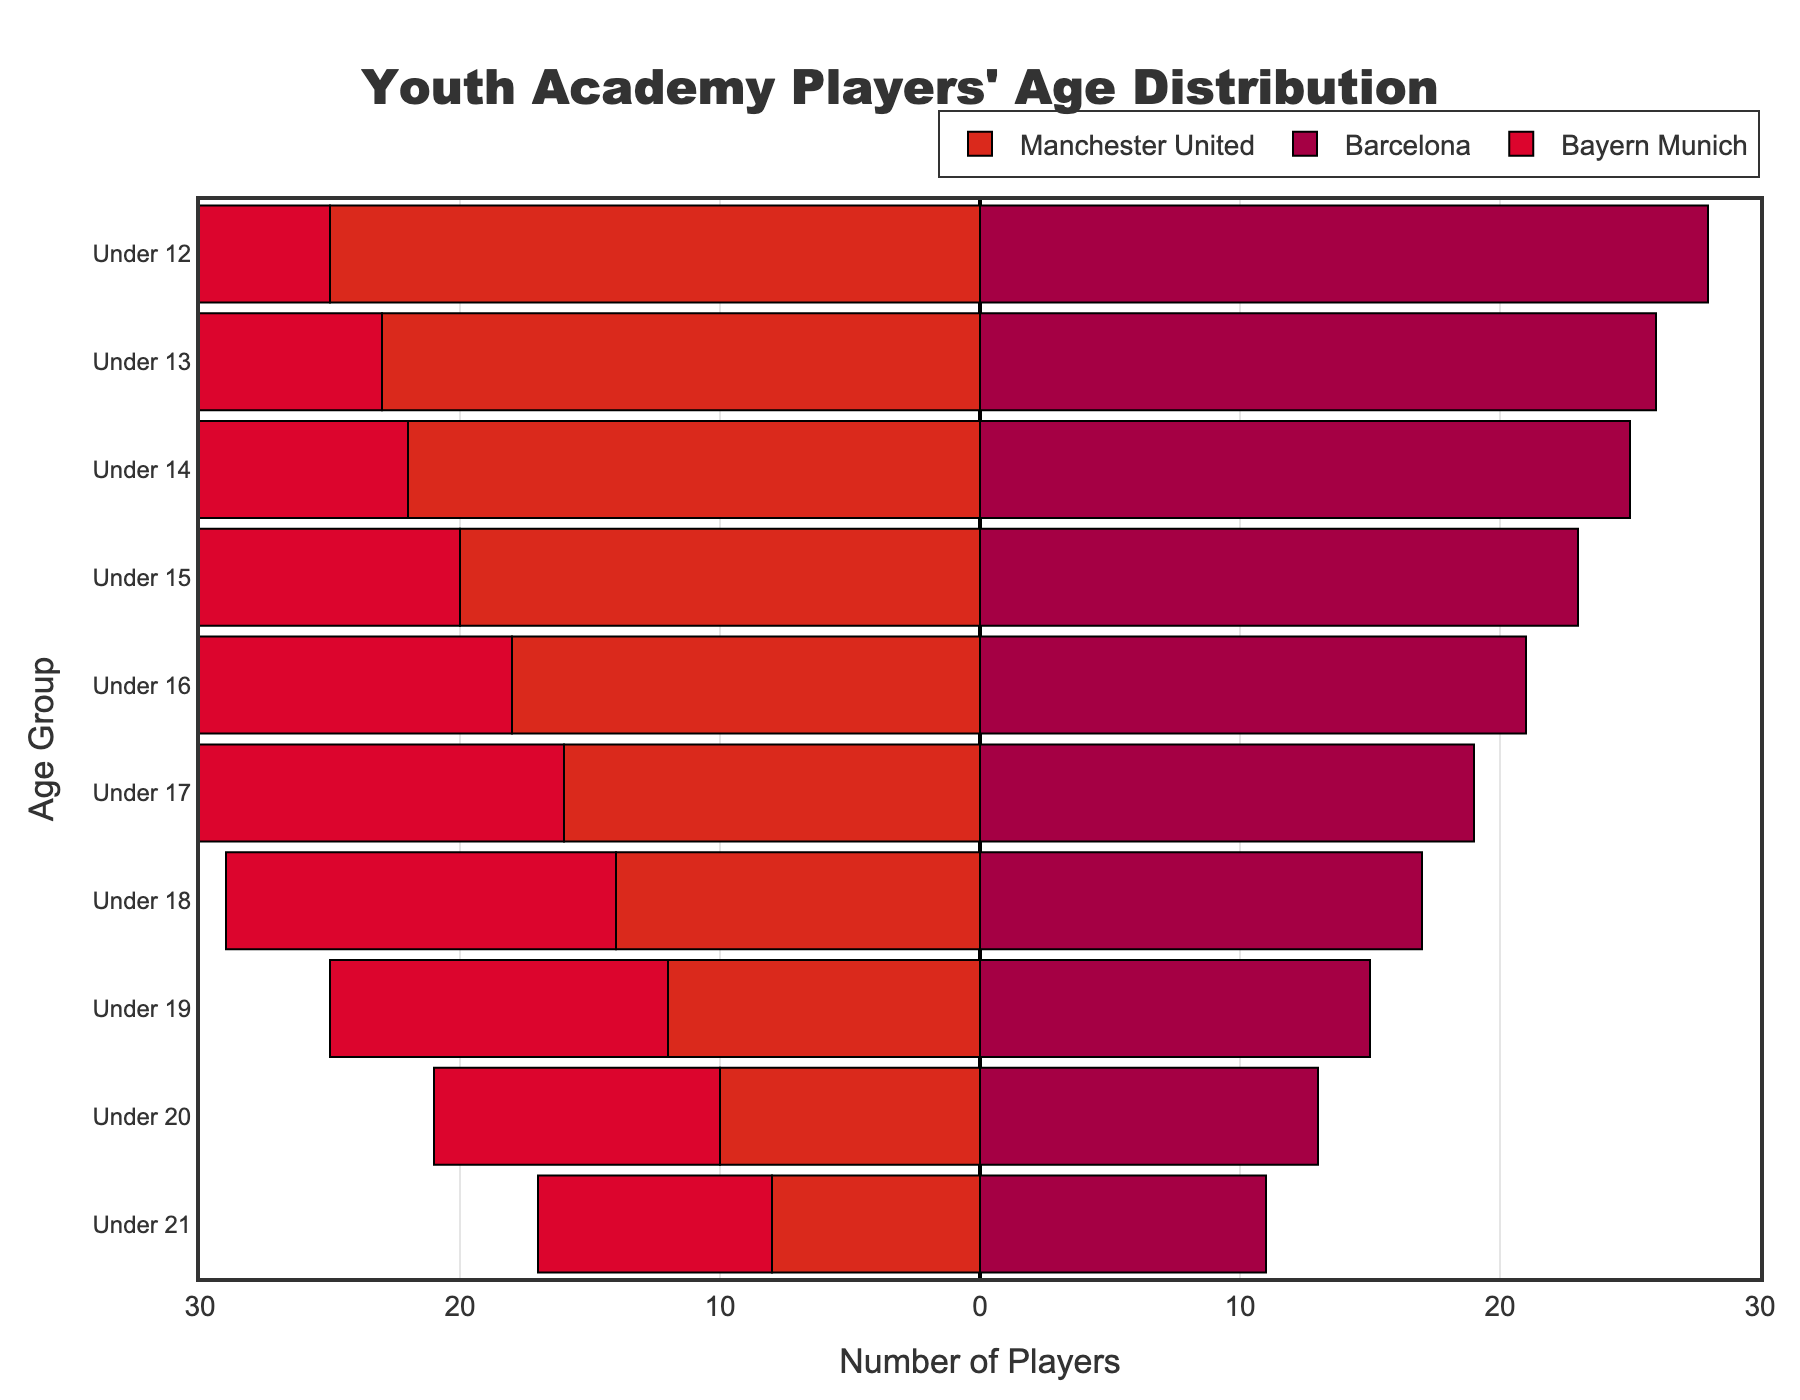What's the number of players for the Under 16 age group at Barcelona? Look at the 'Under 16' age group and check the corresponding bar length for Barcelona.
Answer: 21 How many age groups have more players in Manchester United compared to Bayern Munich? Compare each age group between Manchester United and Bayern Munich and count where Manchester United's values are higher. They are 'Under 12', 'Under 13', 'Under 14', and 'Under 15'.
Answer: 4 What is the difference in the number of players between the Under 12 age group at Manchester United and Bayern Munich? Subtract the number of players in the Under 12 age group of Bayern Munich from Manchester United (25 - 22).
Answer: 3 Which club has the greatest number of players in the Under 21 age group? Look at the 'Under 21' age group and compare the bar lengths for all three clubs. Barcelona has the longest bar.
Answer: Barcelona What is the trend in the number of players as the age groups increase across all clubs? As you go from Under 12 to Under 21, all three clubs show a declining trend in the number of players, indicating fewer players in the older age groups.
Answer: Declining Is there any age group where all three clubs have the exact same number of players? Compare the number of players across all clubs for each age group to find any matches. All groups have different values.
Answer: No What is the total number of players for the Under 15 age group across all clubs? Sum the number of players in the Under 15 age group for Manchester United, Barcelona, and Bayern Munich (20 + 23 + 20).
Answer: 63 How many more players does Barcelona have in the Under 12 age group compared to the Under 19 age group? Subtract the number of players in the Under 19 age group from the Under 12 age group for Barcelona (28 - 15).
Answer: 13 Which club has the most balanced distribution of players across all age groups? Examine the variation in the number of players across age groups for each club. Bayern Munich shows the least variation compared to others.
Answer: Bayern Munich 